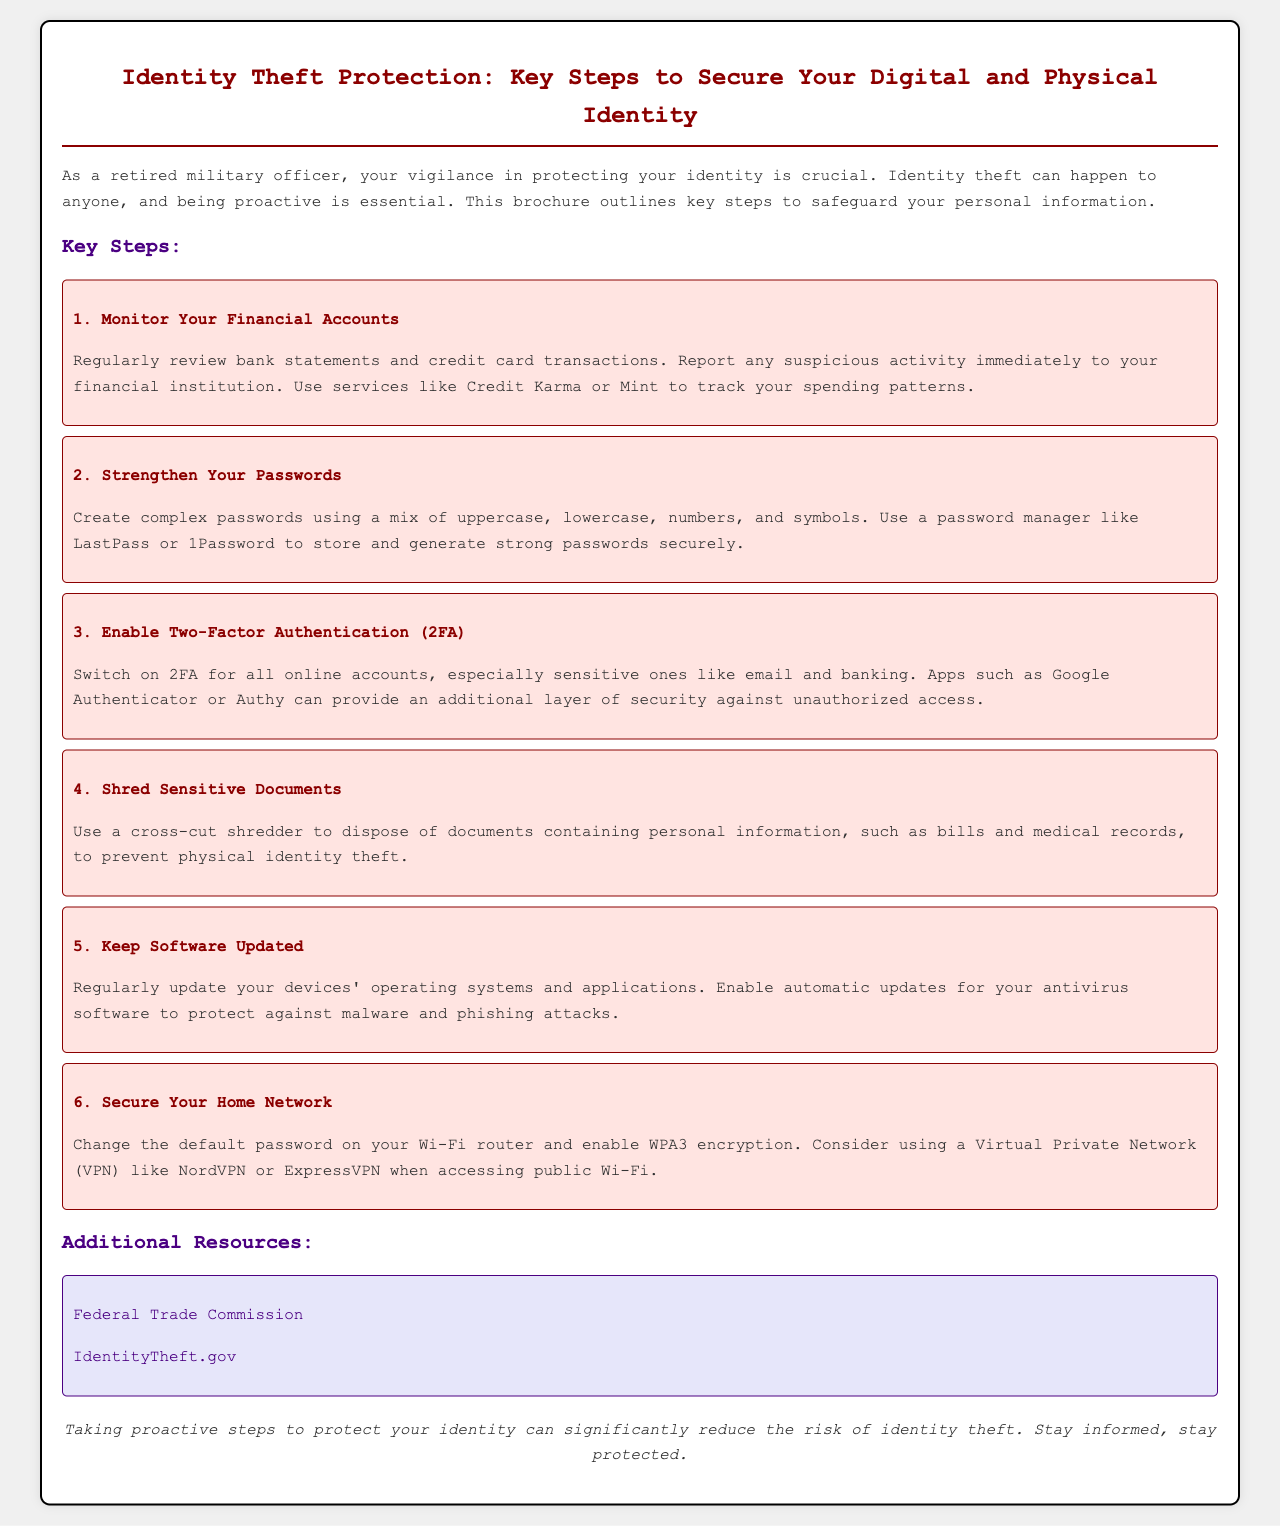What is the title of the brochure? The title of the brochure is clearly stated at the top of the document.
Answer: Identity Theft Protection: Key Steps to Secure Your Digital and Physical Identity How many key steps are outlined in the document? The total number of key steps is explicitly listed in the document.
Answer: 6 What type of shredder is recommended for disposing of sensitive documents? The document specifies a type of shredder that is recommended for use.
Answer: cross-cut shredder What apps are suggested for two-factor authentication? The brochure lists specific applications that can be used for enhanced security.
Answer: Google Authenticator or Authy What is one resource for identity theft information mentioned in the brochure? The document provides links to external resources for additional information on identity theft.
Answer: Federal Trade Commission What action should you take if you find suspicious activity in your financial accounts? The document recommends a specific action to take if suspicious activity is detected.
Answer: Report it immediately What should you enable on your antivirus software to stay protected? The document suggests a specific setting for your antivirus software to maintain security.
Answer: Automatic updates What is one way to secure your home network mentioned in the brochure? The brochure lists a specific method to enhance home network security.
Answer: Change the default password on your Wi-Fi router 